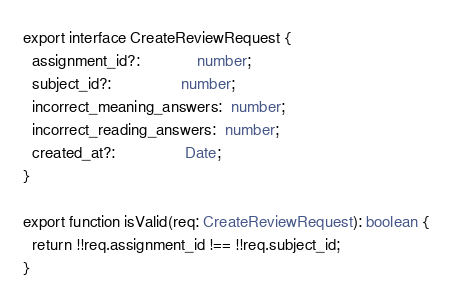<code> <loc_0><loc_0><loc_500><loc_500><_TypeScript_>export interface CreateReviewRequest {
  assignment_id?:             number;
  subject_id?:                number;
  incorrect_meaning_answers:  number;
  incorrect_reading_answers:  number;
  created_at?:                Date;
}

export function isValid(req: CreateReviewRequest): boolean {
  return !!req.assignment_id !== !!req.subject_id;
}</code> 